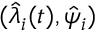Convert formula to latex. <formula><loc_0><loc_0><loc_500><loc_500>( \hat { \lambda } _ { i } ( t ) , \hat { \psi } _ { i } )</formula> 